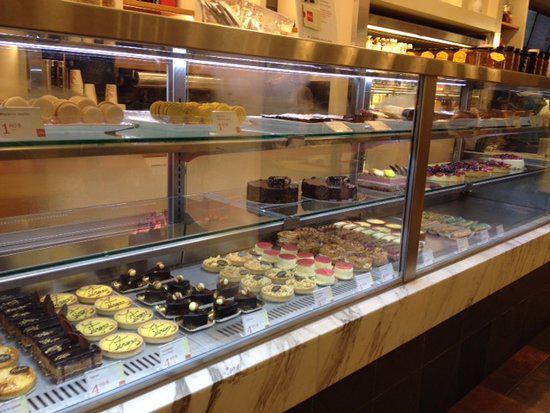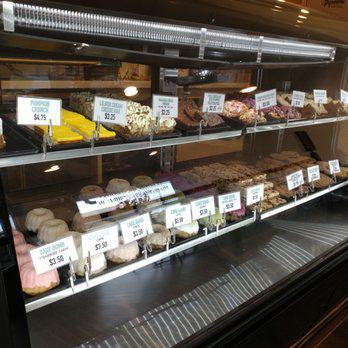The first image is the image on the left, the second image is the image on the right. Considering the images on both sides, is "There are at least 4 full size cakes in one of the images." valid? Answer yes or no. No. 